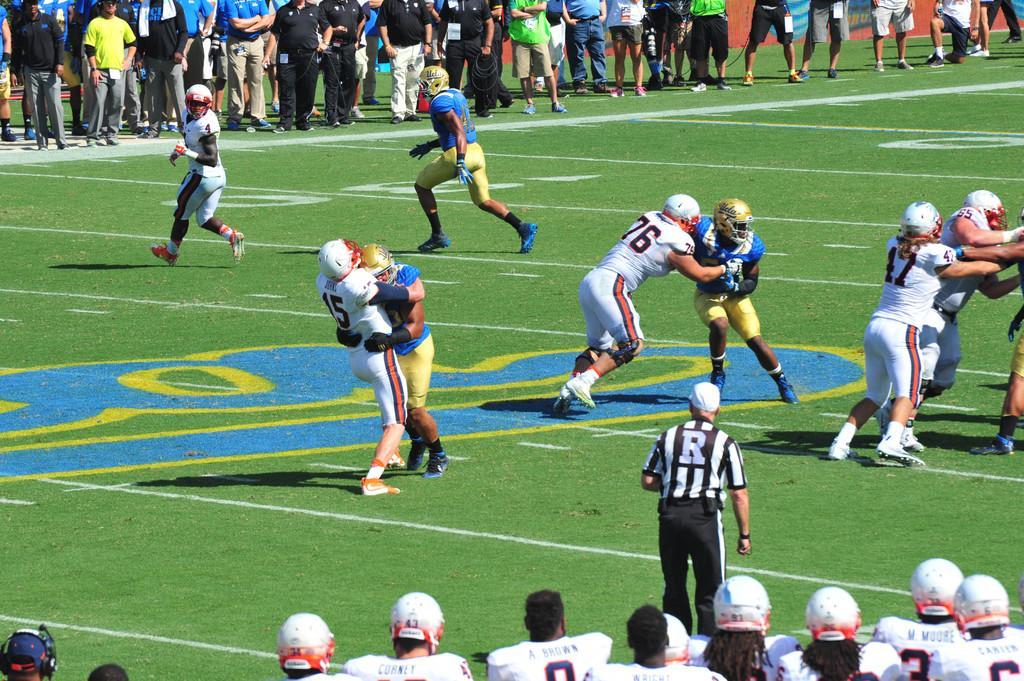Can you describe this image briefly? In this picture we can see some people playing game, at the bottom there is grass, there are some people standing in the background, these people wore helmets. 